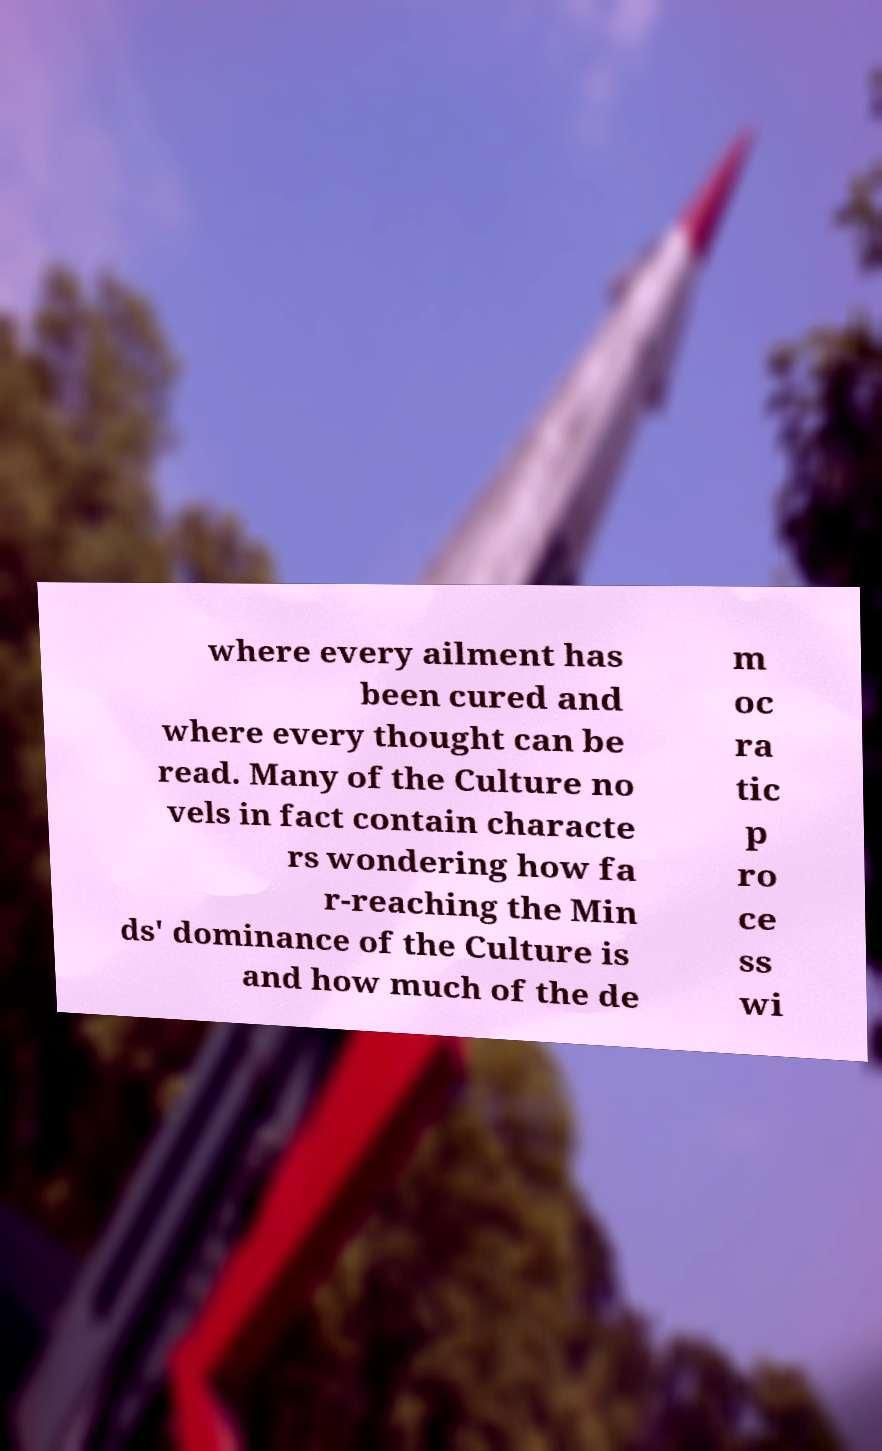Could you extract and type out the text from this image? where every ailment has been cured and where every thought can be read. Many of the Culture no vels in fact contain characte rs wondering how fa r-reaching the Min ds' dominance of the Culture is and how much of the de m oc ra tic p ro ce ss wi 